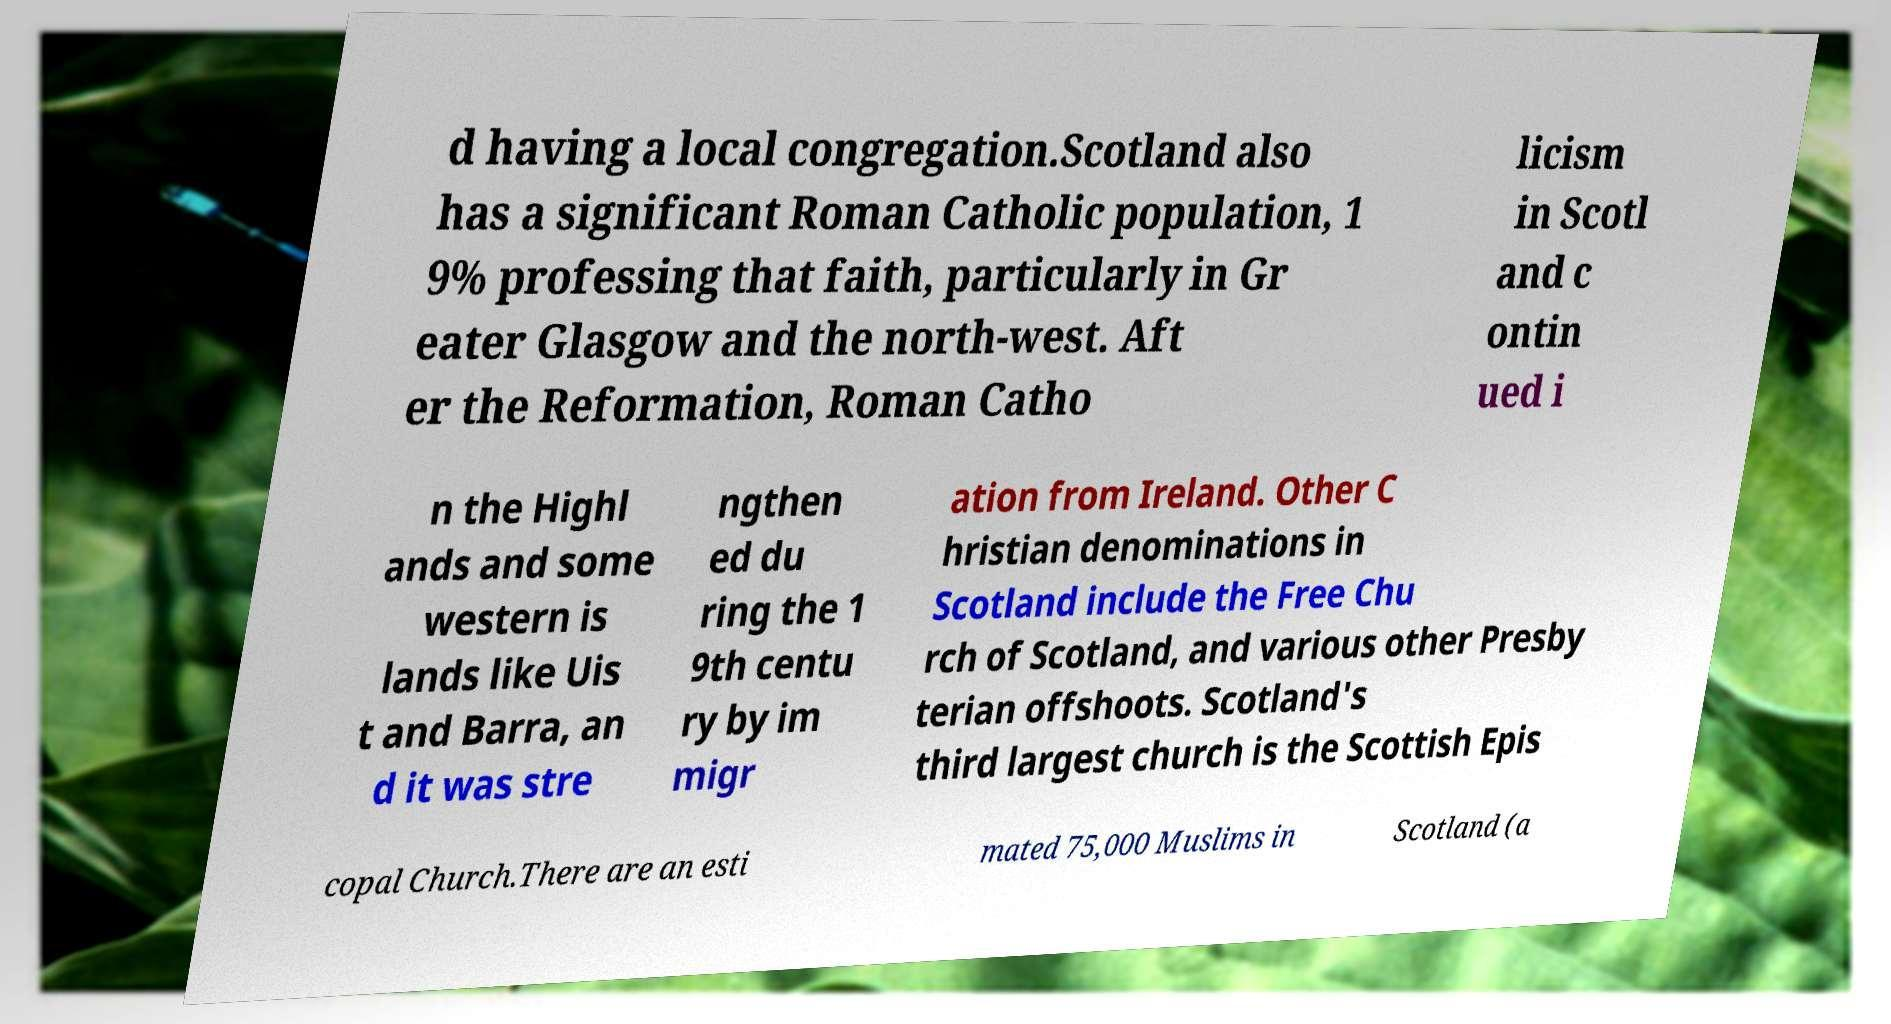Can you accurately transcribe the text from the provided image for me? d having a local congregation.Scotland also has a significant Roman Catholic population, 1 9% professing that faith, particularly in Gr eater Glasgow and the north-west. Aft er the Reformation, Roman Catho licism in Scotl and c ontin ued i n the Highl ands and some western is lands like Uis t and Barra, an d it was stre ngthen ed du ring the 1 9th centu ry by im migr ation from Ireland. Other C hristian denominations in Scotland include the Free Chu rch of Scotland, and various other Presby terian offshoots. Scotland's third largest church is the Scottish Epis copal Church.There are an esti mated 75,000 Muslims in Scotland (a 